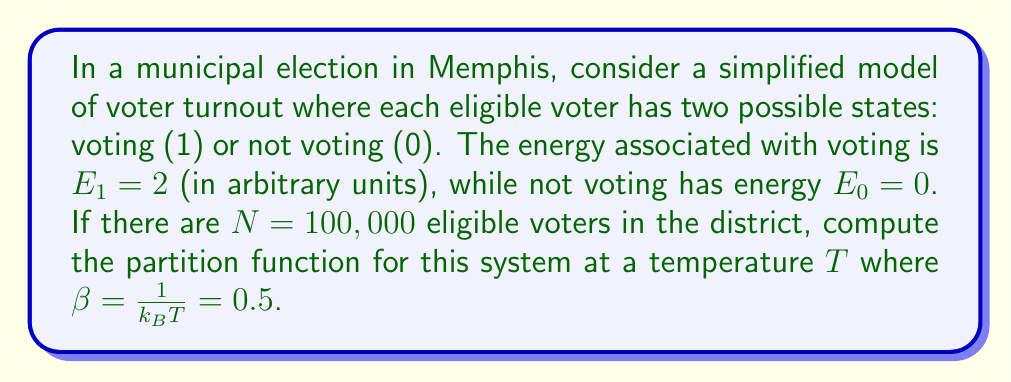Could you help me with this problem? Let's approach this step-by-step:

1) The partition function $Z$ for a system with discrete states is given by:

   $$Z = \sum_i g_i e^{-\beta E_i}$$

   where $g_i$ is the degeneracy of state $i$, $\beta = \frac{1}{k_BT}$, and $E_i$ is the energy of state $i$.

2) In our model, we have two states for each voter:
   - Not voting: $E_0 = 0$, $g_0 = 1$
   - Voting: $E_1 = 2$, $g_1 = 1$

3) For a single voter, the partition function is:

   $$Z_1 = e^{-\beta E_0} + e^{-\beta E_1} = 1 + e^{-2\beta}$$

4) Given $\beta = 0.5$, we can calculate $Z_1$:

   $$Z_1 = 1 + e^{-2(0.5)} = 1 + e^{-1} \approx 1.3679$$

5) Since there are $N = 100,000$ independent voters, and each voter's state is independent of the others, the total partition function is the product of individual partition functions:

   $$Z = (Z_1)^N = (1 + e^{-1})^{100,000}$$

6) Taking the natural log of both sides:

   $$\ln Z = 100,000 \ln(1 + e^{-1}) \approx 31,326.17$$

7) Therefore, the partition function is:

   $$Z = e^{31,326.17}$$
Answer: $Z = e^{31,326.17}$ 